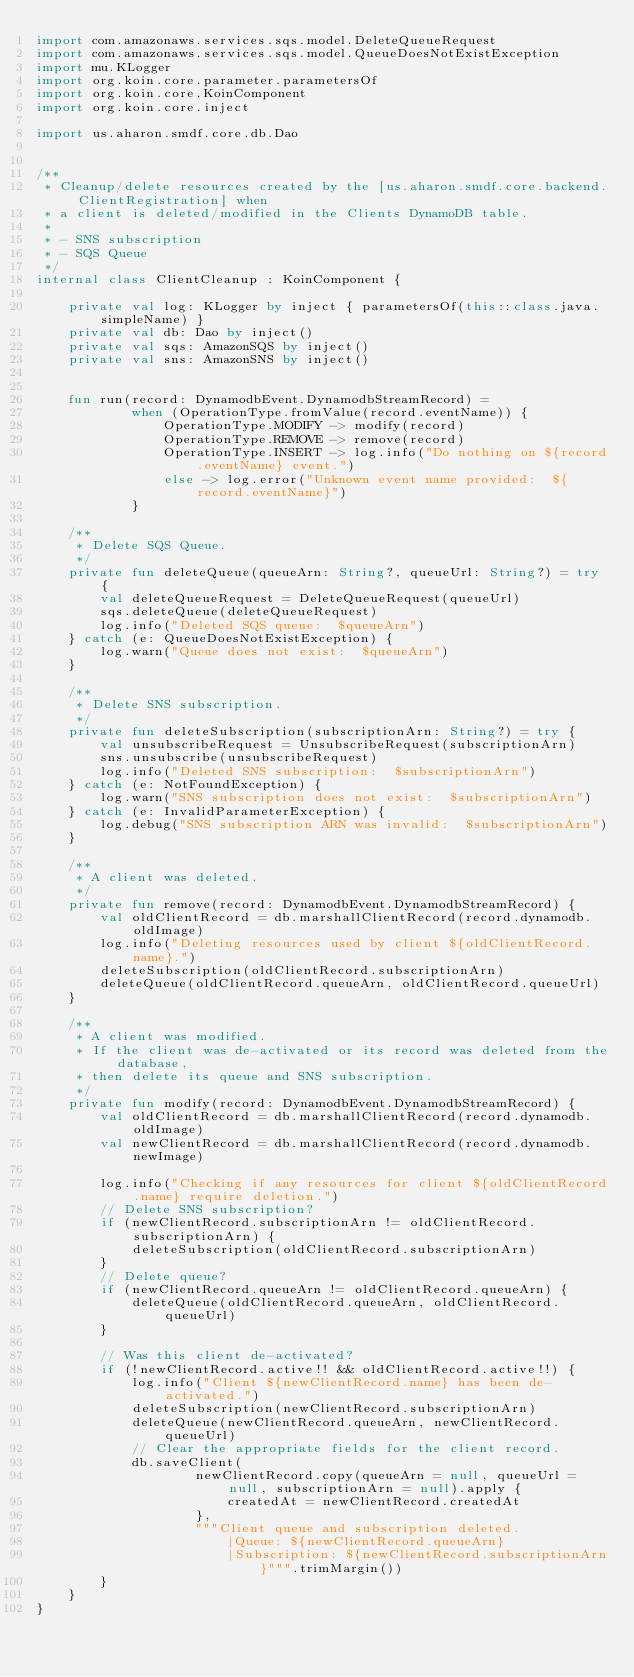Convert code to text. <code><loc_0><loc_0><loc_500><loc_500><_Kotlin_>import com.amazonaws.services.sqs.model.DeleteQueueRequest
import com.amazonaws.services.sqs.model.QueueDoesNotExistException
import mu.KLogger
import org.koin.core.parameter.parametersOf
import org.koin.core.KoinComponent
import org.koin.core.inject

import us.aharon.smdf.core.db.Dao


/**
 * Cleanup/delete resources created by the [us.aharon.smdf.core.backend.ClientRegistration] when
 * a client is deleted/modified in the Clients DynamoDB table.
 *
 * - SNS subscription
 * - SQS Queue
 */
internal class ClientCleanup : KoinComponent {

    private val log: KLogger by inject { parametersOf(this::class.java.simpleName) }
    private val db: Dao by inject()
    private val sqs: AmazonSQS by inject()
    private val sns: AmazonSNS by inject()


    fun run(record: DynamodbEvent.DynamodbStreamRecord) =
            when (OperationType.fromValue(record.eventName)) {
                OperationType.MODIFY -> modify(record)
                OperationType.REMOVE -> remove(record)
                OperationType.INSERT -> log.info("Do nothing on ${record.eventName} event.")
                else -> log.error("Unknown event name provided:  ${record.eventName}")
            }

    /**
     * Delete SQS Queue.
     */
    private fun deleteQueue(queueArn: String?, queueUrl: String?) = try {
        val deleteQueueRequest = DeleteQueueRequest(queueUrl)
        sqs.deleteQueue(deleteQueueRequest)
        log.info("Deleted SQS queue:  $queueArn")
    } catch (e: QueueDoesNotExistException) {
        log.warn("Queue does not exist:  $queueArn")
    }

    /**
     * Delete SNS subscription.
     */
    private fun deleteSubscription(subscriptionArn: String?) = try {
        val unsubscribeRequest = UnsubscribeRequest(subscriptionArn)
        sns.unsubscribe(unsubscribeRequest)
        log.info("Deleted SNS subscription:  $subscriptionArn")
    } catch (e: NotFoundException) {
        log.warn("SNS subscription does not exist:  $subscriptionArn")
    } catch (e: InvalidParameterException) {
        log.debug("SNS subscription ARN was invalid:  $subscriptionArn")
    }

    /**
     * A client was deleted.
     */
    private fun remove(record: DynamodbEvent.DynamodbStreamRecord) {
        val oldClientRecord = db.marshallClientRecord(record.dynamodb.oldImage)
        log.info("Deleting resources used by client ${oldClientRecord.name}.")
        deleteSubscription(oldClientRecord.subscriptionArn)
        deleteQueue(oldClientRecord.queueArn, oldClientRecord.queueUrl)
    }

    /**
     * A client was modified.
     * If the client was de-activated or its record was deleted from the database,
     * then delete its queue and SNS subscription.
     */
    private fun modify(record: DynamodbEvent.DynamodbStreamRecord) {
        val oldClientRecord = db.marshallClientRecord(record.dynamodb.oldImage)
        val newClientRecord = db.marshallClientRecord(record.dynamodb.newImage)

        log.info("Checking if any resources for client ${oldClientRecord.name} require deletion.")
        // Delete SNS subscription?
        if (newClientRecord.subscriptionArn != oldClientRecord.subscriptionArn) {
            deleteSubscription(oldClientRecord.subscriptionArn)
        }
        // Delete queue?
        if (newClientRecord.queueArn != oldClientRecord.queueArn) {
            deleteQueue(oldClientRecord.queueArn, oldClientRecord.queueUrl)
        }

        // Was this client de-activated?
        if (!newClientRecord.active!! && oldClientRecord.active!!) {
            log.info("Client ${newClientRecord.name} has been de-activated.")
            deleteSubscription(newClientRecord.subscriptionArn)
            deleteQueue(newClientRecord.queueArn, newClientRecord.queueUrl)
            // Clear the appropriate fields for the client record.
            db.saveClient(
                    newClientRecord.copy(queueArn = null, queueUrl = null, subscriptionArn = null).apply {
                        createdAt = newClientRecord.createdAt
                    },
                    """Client queue and subscription deleted.
                        |Queue: ${newClientRecord.queueArn}
                        |Subscription: ${newClientRecord.subscriptionArn}""".trimMargin())
        }
    }
}
</code> 